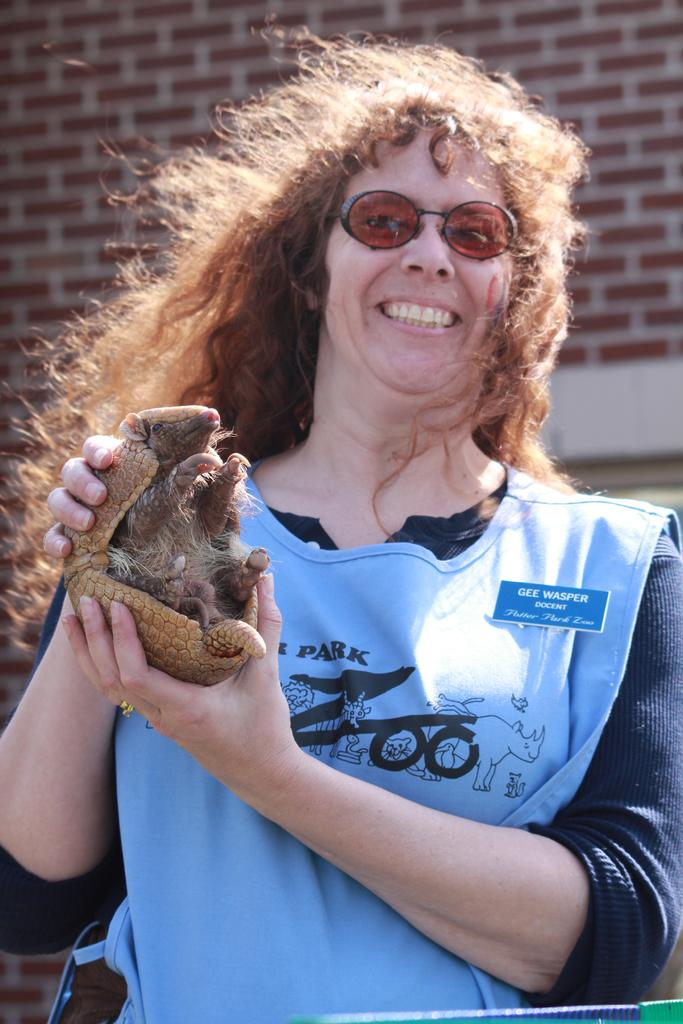Who is present in the image? There is a woman in the image. What is the woman holding? The woman is holding a small armadillo. What expression does the woman have? The woman is smiling. What type of protective eyewear is the woman wearing? The woman is wearing goggles. What type of island can be seen in the background of the image? There is no island present in the image; it features a woman holding an armadillo and wearing goggles. How many sisters does the woman in the image have? The number of sisters the woman has is not mentioned or visible in the image. 